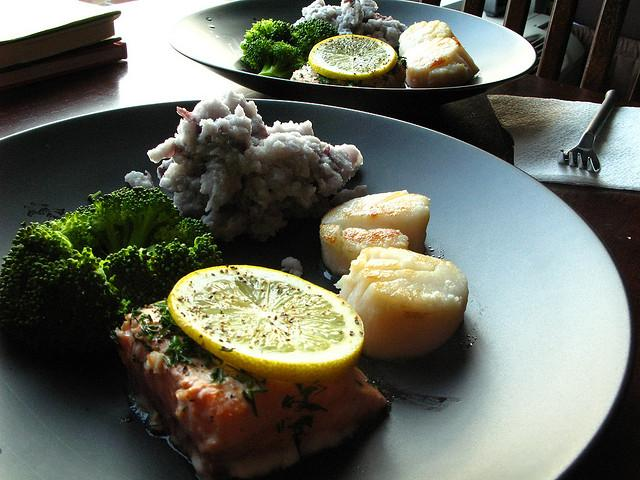Which food here is highest in vitamin B-12?

Choices:
A) broccoli
B) salmon
C) potato
D) scallops salmon 